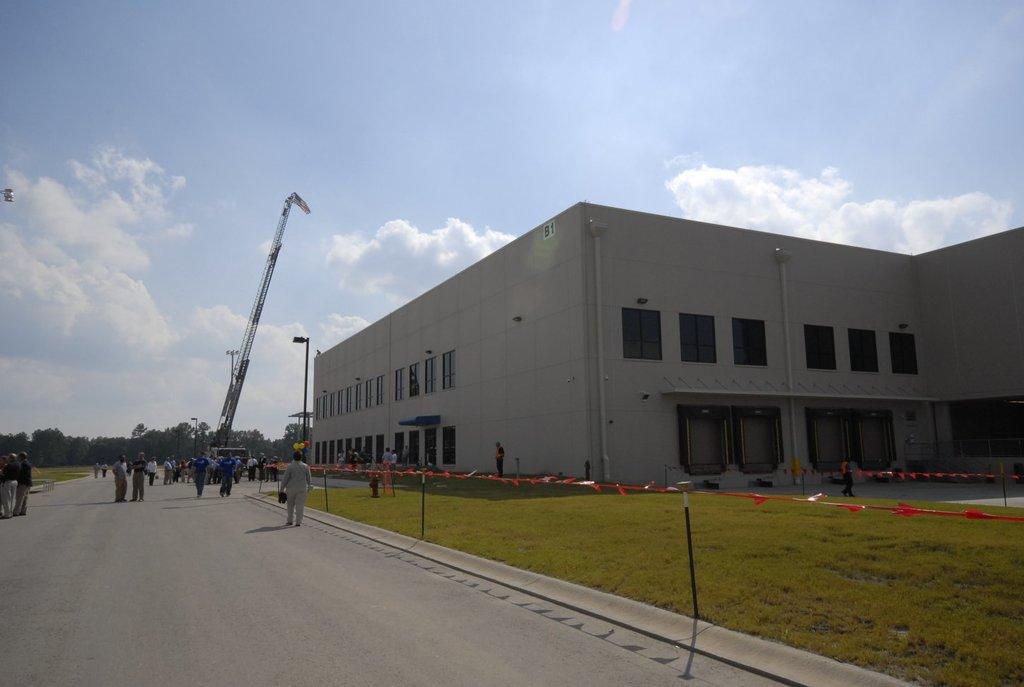In one or two sentences, can you explain what this image depicts? In this image there is one building is at right side of this image and there is some grass at bottom right side of this image and there are some persons are standing in middle of this image. There is a crane machine is at left side of this image and there are some trees in the background. There is a sky at top of this image. There is a road at bottom left side of this image. 